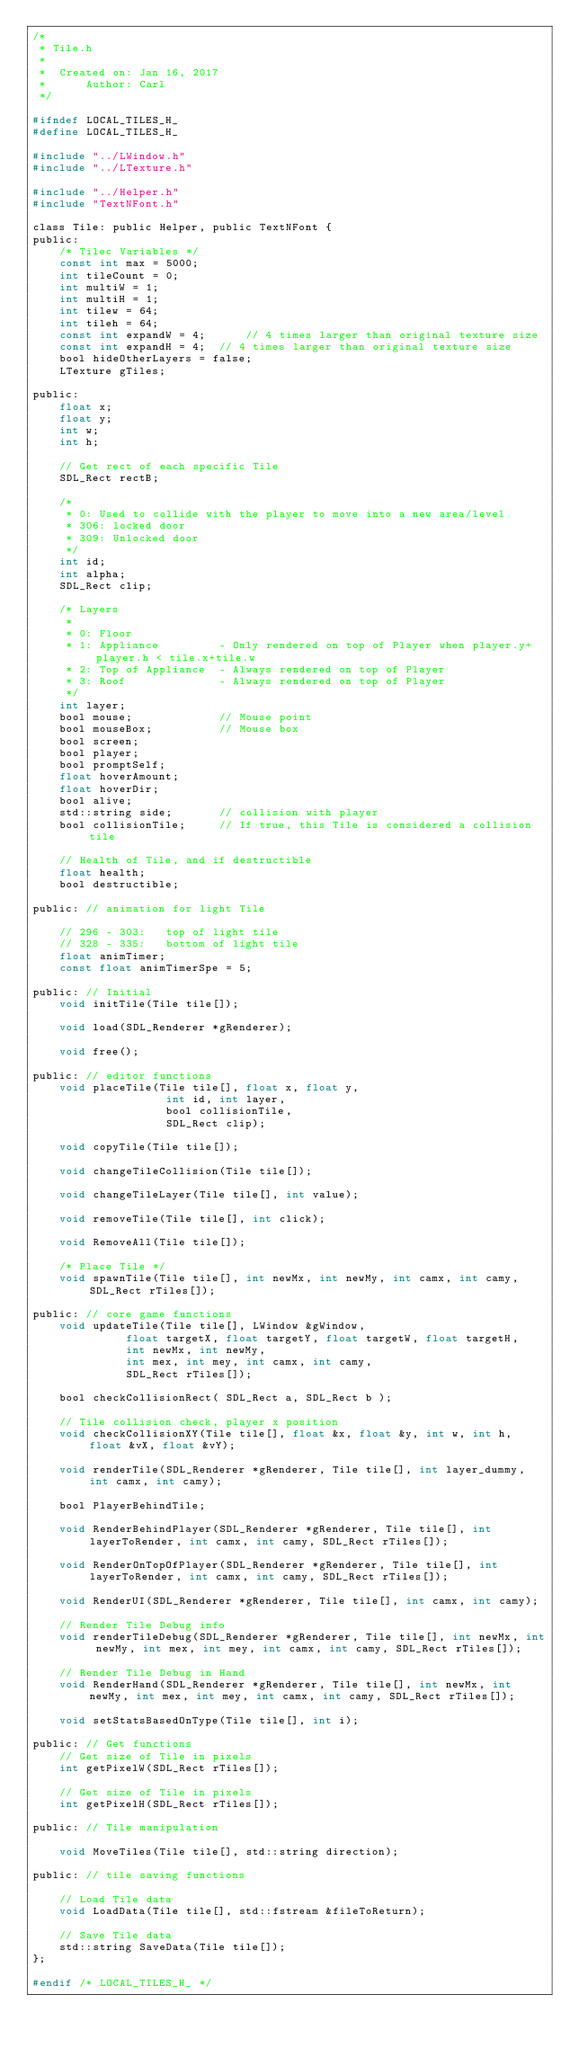<code> <loc_0><loc_0><loc_500><loc_500><_C_>/*
 * Tile.h
 *
 *  Created on: Jan 16, 2017
 *      Author: Carl
 */

#ifndef LOCAL_TILES_H_
#define LOCAL_TILES_H_

#include "../LWindow.h"
#include "../LTexture.h"

#include "../Helper.h"
#include "TextNFont.h"

class Tile: public Helper, public TextNFont {
public:
	/* Tilec Variables */
	const int max = 5000;
	int tileCount = 0;
	int multiW = 1;
	int multiH = 1;
	int tilew = 64;
	int tileh = 64;
	const int expandW = 4;		// 4 times larger than original texture size
	const int expandH = 4;	// 4 times larger than original texture size
	bool hideOtherLayers = false;
	LTexture gTiles;

public:
	float x;
	float y;
	int w;
	int h;

	// Get rect of each specific Tile
	SDL_Rect rectB;

	/*
	 * 0: Used to collide with the player to move into a new area/level
	 * 306: locked door
	 * 309: Unlocked door
	 */
	int id;
	int alpha;
	SDL_Rect clip;

	/* Layers
	 *
	 * 0: Floor
	 * 1: Appliance			- Only rendered on top of Player when player.y+player.h < tile.x+tile.w
	 * 2: Top of Appliance	- Always rendered on top of Player
	 * 3: Roof 				- Always rendered on top of Player
	 */
	int layer;
	bool mouse;				// Mouse point
	bool mouseBox;			// Mouse box
	bool screen;
	bool player;
	bool promptSelf;
	float hoverAmount;
	float hoverDir;
	bool alive;
	std::string side;		// collision with player
	bool collisionTile;		// If true, this Tile is considered a collision tile

	// Health of Tile, and if destructible
	float health;
	bool destructible;

public:	// animation for light Tile

	// 296 - 303:	top of light tile
	// 328 - 335:	bottom of light tile
	float animTimer;
	const float animTimerSpe = 5;

public:	// Initial
	void initTile(Tile tile[]);

	void load(SDL_Renderer *gRenderer);

	void free();

public:	// editor functions
	void placeTile(Tile tile[], float x, float y,
					int id, int layer,
					bool collisionTile,
					SDL_Rect clip);

	void copyTile(Tile tile[]);

	void changeTileCollision(Tile tile[]);

	void changeTileLayer(Tile tile[], int value);

	void removeTile(Tile tile[], int click);

	void RemoveAll(Tile tile[]);

	/* Place Tile */
	void spawnTile(Tile tile[], int newMx, int newMy, int camx, int camy, SDL_Rect rTiles[]);

public:	// core game functions
	void updateTile(Tile tile[], LWindow &gWindow,
			  float targetX, float targetY, float targetW, float targetH,
			  int newMx, int newMy,
			  int mex, int mey, int camx, int camy,
			  SDL_Rect rTiles[]);

	bool checkCollisionRect( SDL_Rect a, SDL_Rect b );

	// Tile collision check, player x position
	void checkCollisionXY(Tile tile[], float &x, float &y, int w, int h, float &vX, float &vY);

	void renderTile(SDL_Renderer *gRenderer, Tile tile[], int layer_dummy, int camx, int camy);

	bool PlayerBehindTile;

	void RenderBehindPlayer(SDL_Renderer *gRenderer, Tile tile[], int layerToRender, int camx, int camy, SDL_Rect rTiles[]);

	void RenderOnTopOfPlayer(SDL_Renderer *gRenderer, Tile tile[], int layerToRender, int camx, int camy, SDL_Rect rTiles[]);

	void RenderUI(SDL_Renderer *gRenderer, Tile tile[], int camx, int camy);

	// Render Tile Debug info
	void renderTileDebug(SDL_Renderer *gRenderer, Tile tile[], int newMx, int newMy, int mex, int mey, int camx, int camy, SDL_Rect rTiles[]);

	// Render Tile Debug in Hand
	void RenderHand(SDL_Renderer *gRenderer, Tile tile[], int newMx, int newMy, int mex, int mey, int camx, int camy, SDL_Rect rTiles[]);

	void setStatsBasedOnType(Tile tile[], int i);

public:	// Get functions
	// Get size of Tile in pixels
	int getPixelW(SDL_Rect rTiles[]);

	// Get size of Tile in pixels
	int getPixelH(SDL_Rect rTiles[]);

public:	// Tile manipulation

	void MoveTiles(Tile tile[], std::string direction);

public: // tile saving functions

	// Load Tile data
	void LoadData(Tile tile[], std::fstream &fileToReturn);

	// Save Tile data
	std::string SaveData(Tile tile[]);
};

#endif /* LOCAL_TILES_H_ */
</code> 